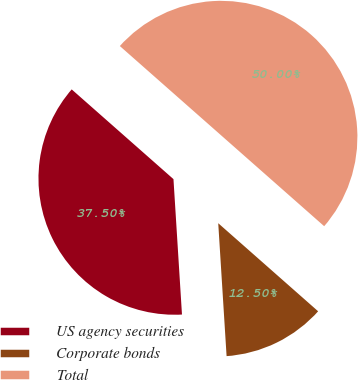Convert chart. <chart><loc_0><loc_0><loc_500><loc_500><pie_chart><fcel>US agency securities<fcel>Corporate bonds<fcel>Total<nl><fcel>37.5%<fcel>12.5%<fcel>50.0%<nl></chart> 